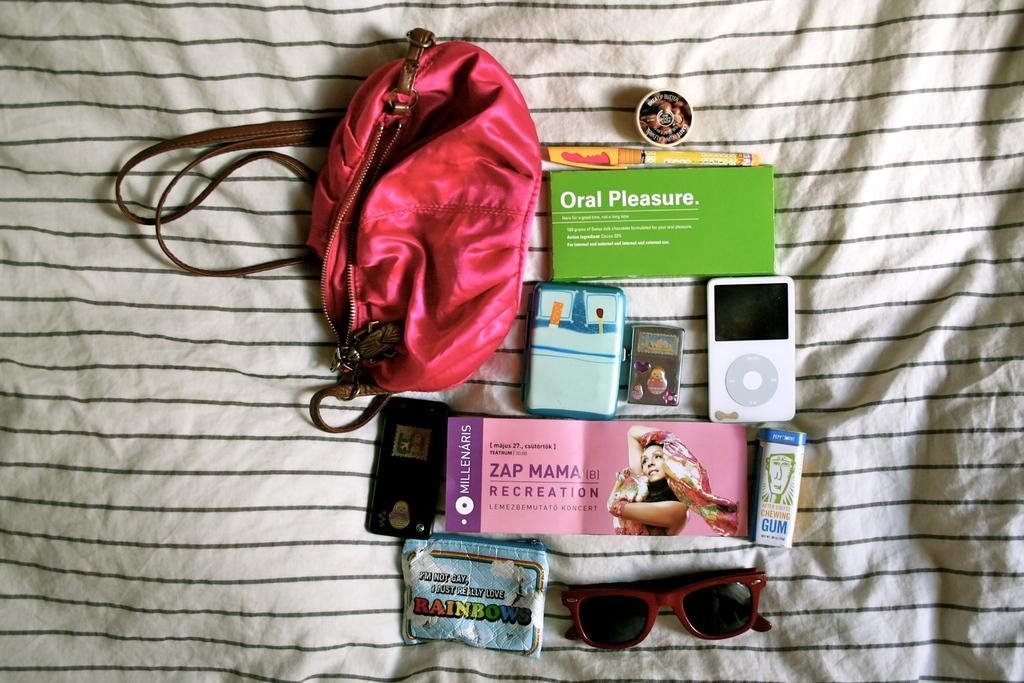What type of accessory is present in the image? There are sunglasses in the image. What type of snack is visible in the image? There is a chips packet in the image. What type of container is present in the image? There is a bag in the image. What type of cosmetic item is present in the image? There is a lip balm in the image. What type of writing instrument is present in the image? There is a pen in the image. What type of music player is present in the image? There is an iPod and a walkman in the image. What type of accessory is present for carrying personal items? There is a purse in the image. What type of trees are growing in the image? There are no trees present in the image. What is the temperature of the items in the image? The temperature of the items in the image cannot be determined from the image itself. How much sugar is present in the image? There is no sugar present in the image. 